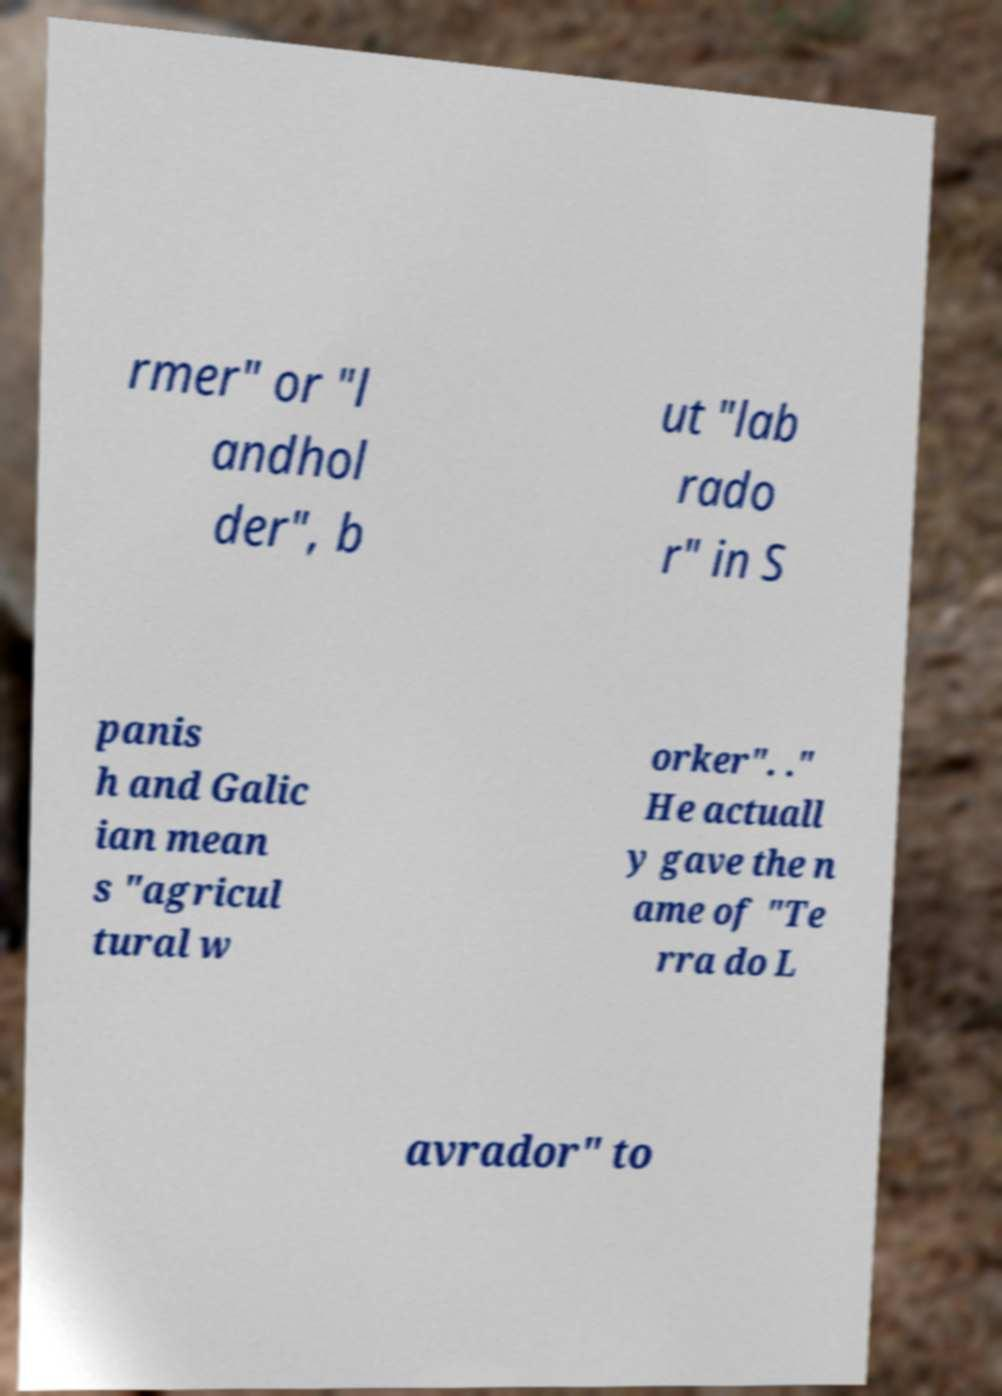Can you accurately transcribe the text from the provided image for me? rmer" or "l andhol der", b ut "lab rado r" in S panis h and Galic ian mean s "agricul tural w orker". ." He actuall y gave the n ame of "Te rra do L avrador" to 